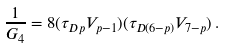<formula> <loc_0><loc_0><loc_500><loc_500>\frac { 1 } { G _ { 4 } } = 8 ( \tau _ { D p } V _ { p - 1 } ) ( \tau _ { D ( 6 - p ) } V _ { 7 - p } ) \, .</formula> 